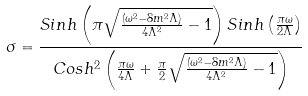Convert formula to latex. <formula><loc_0><loc_0><loc_500><loc_500>\sigma = \frac { S i n h \left ( \pi \sqrt { \frac { ( \omega ^ { 2 } - 8 m ^ { 2 } \Lambda ) } { 4 \Lambda ^ { 2 } } - 1 } \right ) S i n h \left ( \frac { \pi \omega } { 2 \Lambda } \right ) } { C o s h ^ { 2 } \left ( \frac { \pi \omega } { 4 \Lambda } + \frac { \pi } { 2 } \sqrt { \frac { ( \omega ^ { 2 } - 8 m ^ { 2 } \Lambda ) } { 4 \Lambda ^ { 2 } } - 1 } \right ) }</formula> 